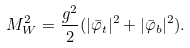<formula> <loc_0><loc_0><loc_500><loc_500>M ^ { 2 } _ { W } = \frac { g ^ { 2 } } { 2 } ( | \bar { \varphi } _ { t } | ^ { 2 } + | \bar { \varphi } _ { b } | ^ { 2 } ) .</formula> 